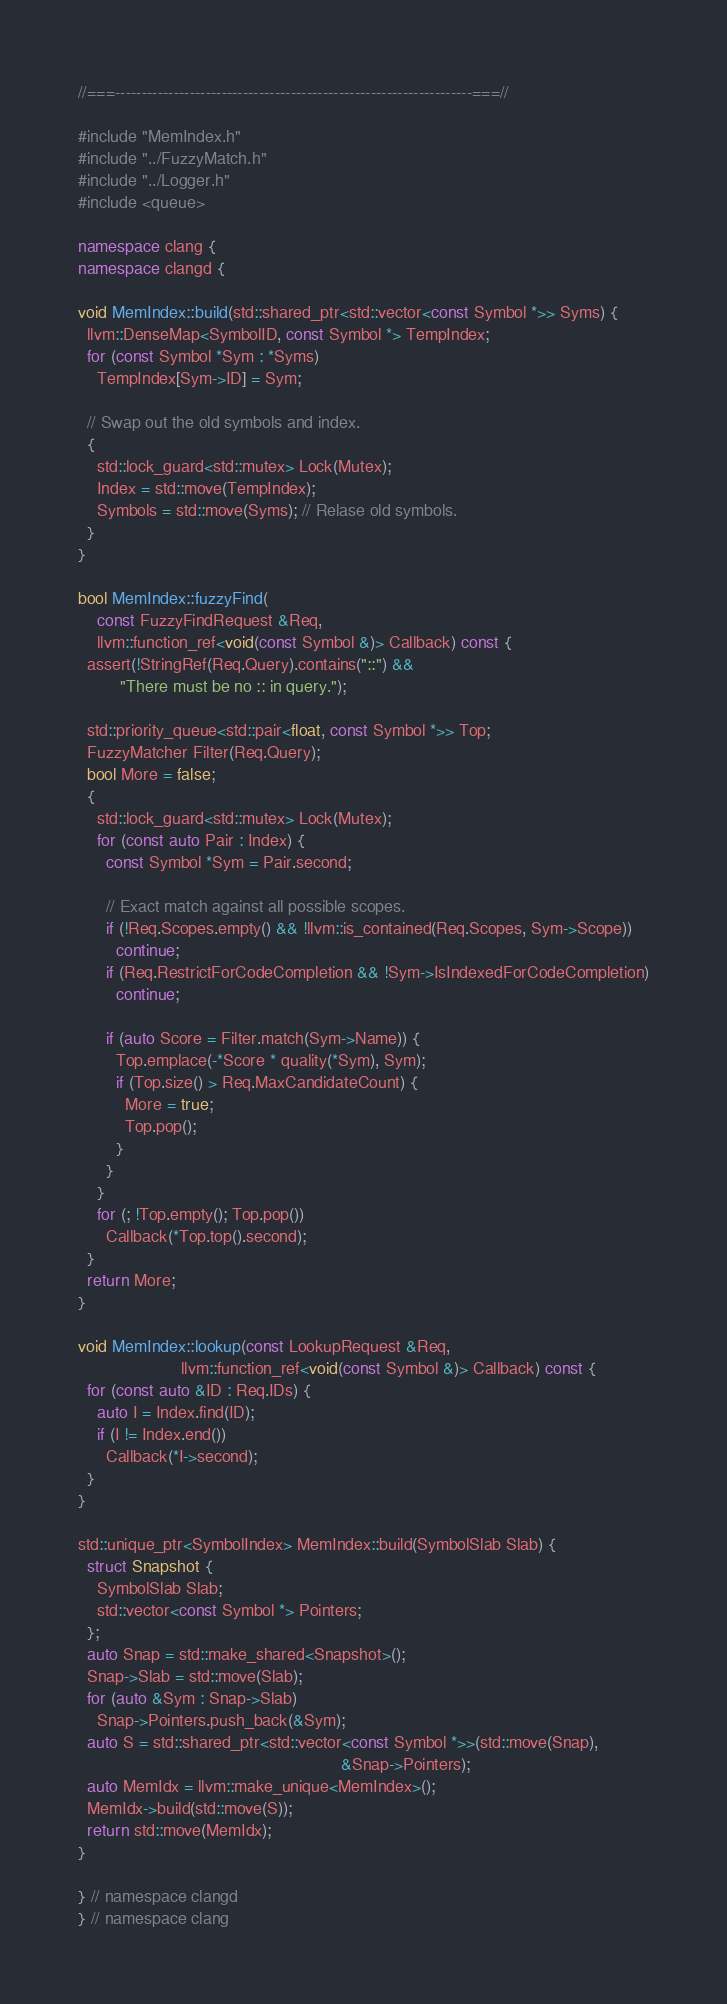<code> <loc_0><loc_0><loc_500><loc_500><_C++_>//===-------------------------------------------------------------------===//

#include "MemIndex.h"
#include "../FuzzyMatch.h"
#include "../Logger.h"
#include <queue>

namespace clang {
namespace clangd {

void MemIndex::build(std::shared_ptr<std::vector<const Symbol *>> Syms) {
  llvm::DenseMap<SymbolID, const Symbol *> TempIndex;
  for (const Symbol *Sym : *Syms)
    TempIndex[Sym->ID] = Sym;

  // Swap out the old symbols and index.
  {
    std::lock_guard<std::mutex> Lock(Mutex);
    Index = std::move(TempIndex);
    Symbols = std::move(Syms); // Relase old symbols.
  }
}

bool MemIndex::fuzzyFind(
    const FuzzyFindRequest &Req,
    llvm::function_ref<void(const Symbol &)> Callback) const {
  assert(!StringRef(Req.Query).contains("::") &&
         "There must be no :: in query.");

  std::priority_queue<std::pair<float, const Symbol *>> Top;
  FuzzyMatcher Filter(Req.Query);
  bool More = false;
  {
    std::lock_guard<std::mutex> Lock(Mutex);
    for (const auto Pair : Index) {
      const Symbol *Sym = Pair.second;

      // Exact match against all possible scopes.
      if (!Req.Scopes.empty() && !llvm::is_contained(Req.Scopes, Sym->Scope))
        continue;
      if (Req.RestrictForCodeCompletion && !Sym->IsIndexedForCodeCompletion)
        continue;

      if (auto Score = Filter.match(Sym->Name)) {
        Top.emplace(-*Score * quality(*Sym), Sym);
        if (Top.size() > Req.MaxCandidateCount) {
          More = true;
          Top.pop();
        }
      }
    }
    for (; !Top.empty(); Top.pop())
      Callback(*Top.top().second);
  }
  return More;
}

void MemIndex::lookup(const LookupRequest &Req,
                      llvm::function_ref<void(const Symbol &)> Callback) const {
  for (const auto &ID : Req.IDs) {
    auto I = Index.find(ID);
    if (I != Index.end())
      Callback(*I->second);
  }
}

std::unique_ptr<SymbolIndex> MemIndex::build(SymbolSlab Slab) {
  struct Snapshot {
    SymbolSlab Slab;
    std::vector<const Symbol *> Pointers;
  };
  auto Snap = std::make_shared<Snapshot>();
  Snap->Slab = std::move(Slab);
  for (auto &Sym : Snap->Slab)
    Snap->Pointers.push_back(&Sym);
  auto S = std::shared_ptr<std::vector<const Symbol *>>(std::move(Snap),
                                                        &Snap->Pointers);
  auto MemIdx = llvm::make_unique<MemIndex>();
  MemIdx->build(std::move(S));
  return std::move(MemIdx);
}

} // namespace clangd
} // namespace clang
</code> 